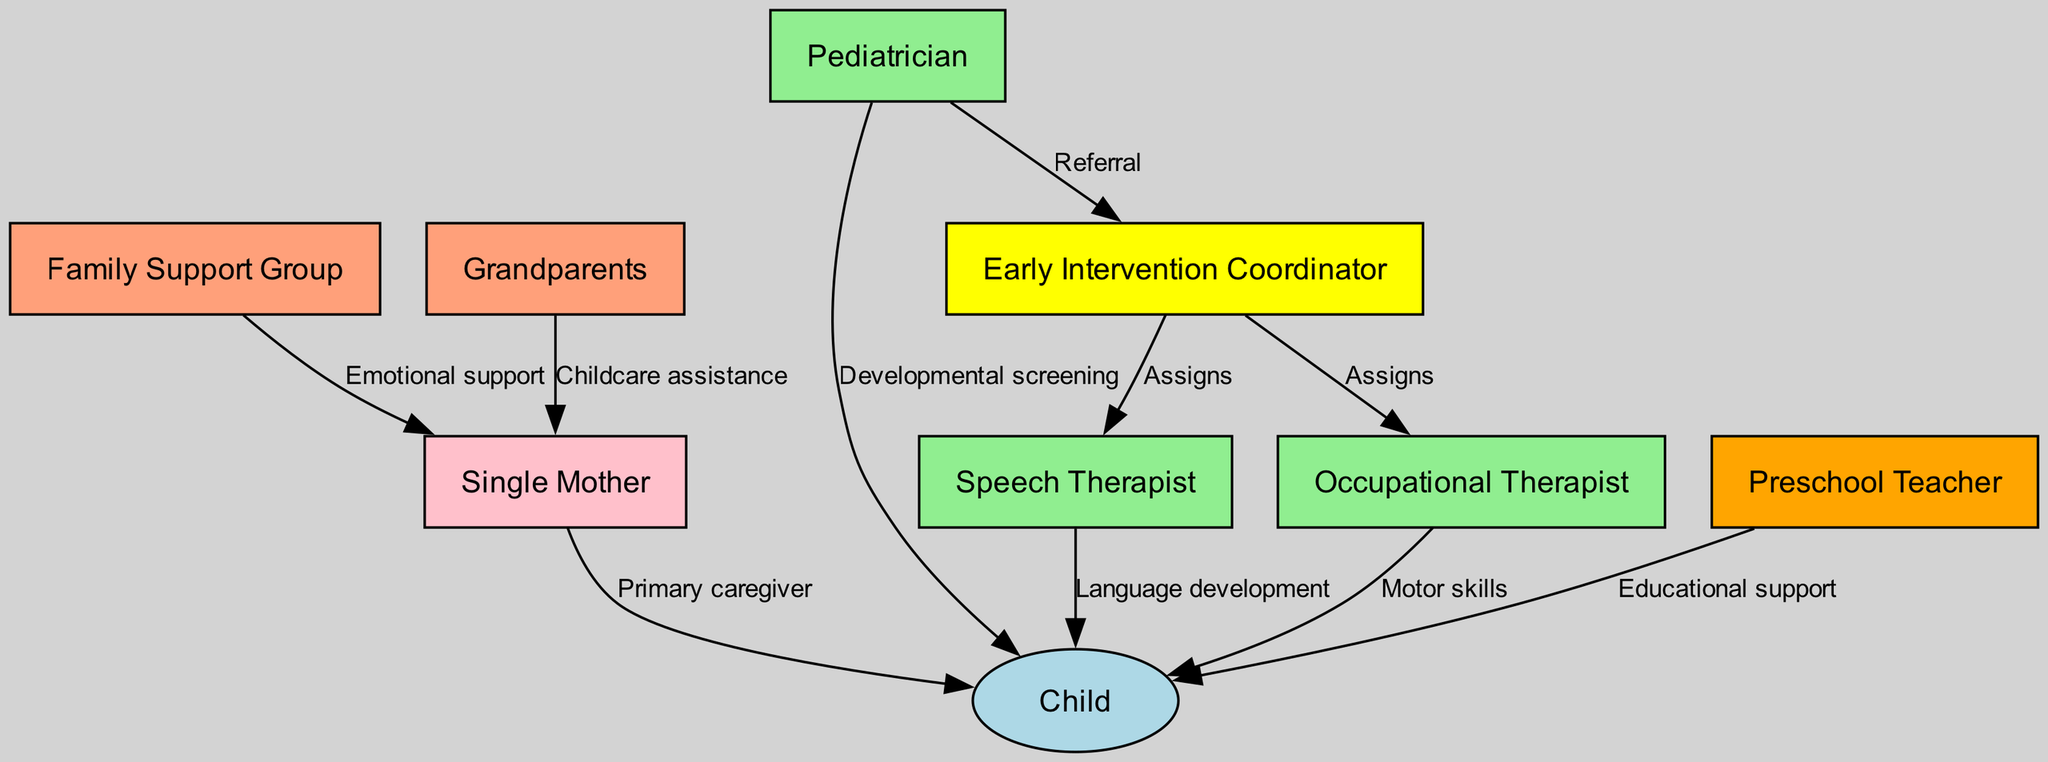What is the primary role of the Single Mother in the diagram? The Single Mother is connected to the Child with the label "Primary caregiver," indicating that her role primarily involves caring for the child.
Answer: Primary caregiver How many different professionals are involved in the child's early intervention journey? The diagram shows four professionals: Pediatrician, Speech Therapist, Occupational Therapist, and Preschool Teacher.
Answer: Four What type of support does the Family Support Group provide to the Single Mother? The Family Support Group connects to the Single Mother with the label "Emotional support," indicating they provide emotional assistance.
Answer: Emotional support Who assigns the Speech Therapist and Occupational Therapist? The Early Intervention Coordinator connects to both the Speech Therapist and Occupational Therapist with the label "Assigns," indicating that this coordinator is responsible for making these assignments.
Answer: Early Intervention Coordinator What is the relationship between the Pediatrician and the Early Intervention Coordinator? The Pediatrician is connected to the Early Intervention Coordinator with the label "Referral," indicating that the pediatrician refers the child to this coordinator for further intervention services.
Answer: Referral How does the Occupational Therapist contribute to the Child's development? The Occupational Therapist is connected to the Child with the label "Motor skills," showing that their focus is on enhancing the child's motor skills.
Answer: Motor skills What assistance do the Grandparents provide to the Single Mother? The Grandparents are linked to the Single Mother with the label "Childcare assistance," indicating that their role includes helping with childcare duties.
Answer: Childcare assistance What is the purpose of the connection between the Preschool Teacher and the Child? The Preschool Teacher connects to the Child with the label "Educational support," indicating their role in providing educational resources to the child.
Answer: Educational support Which node is the central point connected to multiple professionals in the diagram? The Early Intervention Coordinator is connected to both Speech Therapist and Occupational Therapist, as well as being linked to the Pediatrician, making it the central hub for professionals involved.
Answer: Early Intervention Coordinator 